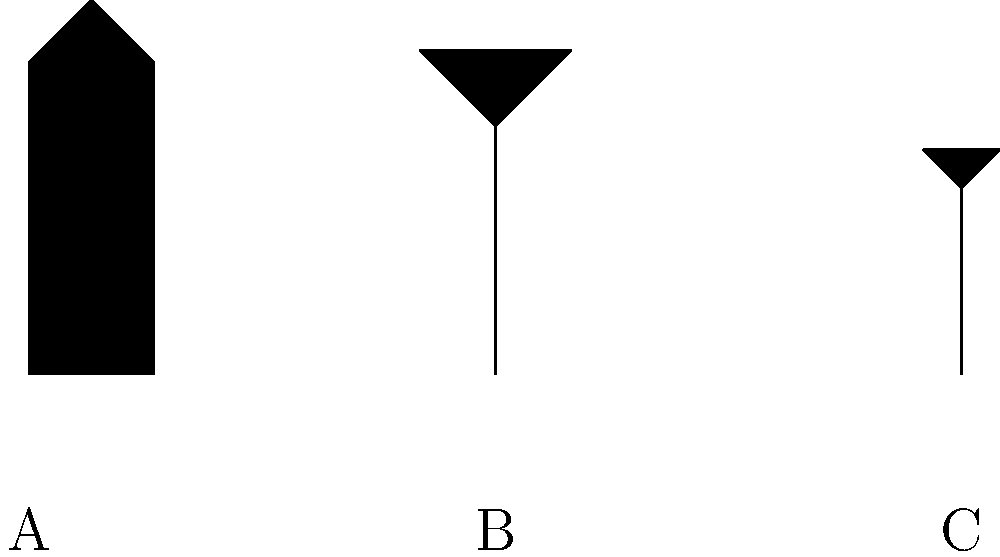Which silhouette represents 'The Tick' character in the image above? To identify 'The Tick' character from the silhouettes, let's analyze each shape:

1. Silhouette A (left):
   - Tall, rectangular shape
   - Distinctive antenna-like protrusions at the top
   - Resembles 'The Tick's iconic muscular build and antennae

2. Silhouette B (center):
   - Shorter, wider shape
   - Round head with ear-like protrusions
   - Resembles Arthur, 'The Tick's sidekick, in his moth suit

3. Silhouette C (right):
   - Smallest silhouette
   - Round shape with slight protrusions at the top
   - Could represent a minor character or villain

Based on these observations, the silhouette that most closely matches 'The Tick's distinctive appearance is Silhouette A. The tall, rectangular shape with antenna-like protrusions is a clear representation of 'The Tick's superhero costume and physique.
Answer: A 